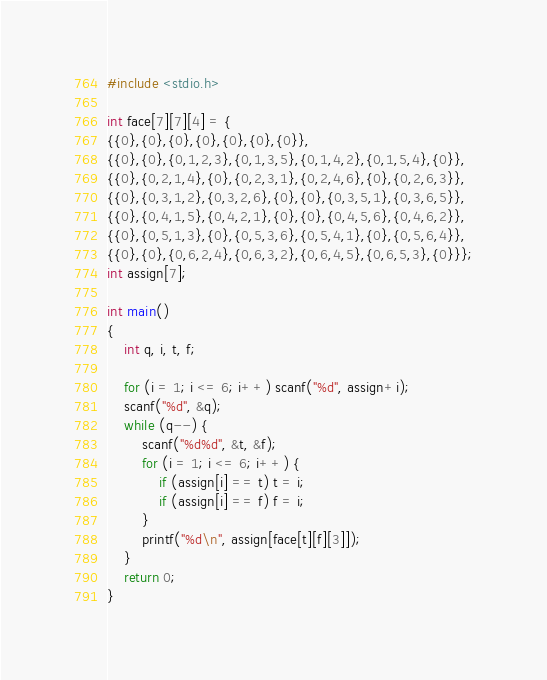<code> <loc_0><loc_0><loc_500><loc_500><_C_>#include <stdio.h>

int face[7][7][4] = {
{{0},{0},{0},{0},{0},{0},{0}},
{{0},{0},{0,1,2,3},{0,1,3,5},{0,1,4,2},{0,1,5,4},{0}},
{{0},{0,2,1,4},{0},{0,2,3,1},{0,2,4,6},{0},{0,2,6,3}},
{{0},{0,3,1,2},{0,3,2,6},{0},{0},{0,3,5,1},{0,3,6,5}},
{{0},{0,4,1,5},{0,4,2,1},{0},{0},{0,4,5,6},{0,4,6,2}},
{{0},{0,5,1,3},{0},{0,5,3,6},{0,5,4,1},{0},{0,5,6,4}},
{{0},{0},{0,6,2,4},{0,6,3,2},{0,6,4,5},{0,6,5,3},{0}}};
int assign[7];

int main()
{
	int q, i, t, f;

	for (i = 1; i <= 6; i++) scanf("%d", assign+i);
	scanf("%d", &q);
	while (q--) {
		scanf("%d%d", &t, &f);
		for (i = 1; i <= 6; i++) {
			if (assign[i] == t) t = i;
			if (assign[i] == f) f = i;
		}
		printf("%d\n", assign[face[t][f][3]]);
	}
	return 0;
}

</code> 